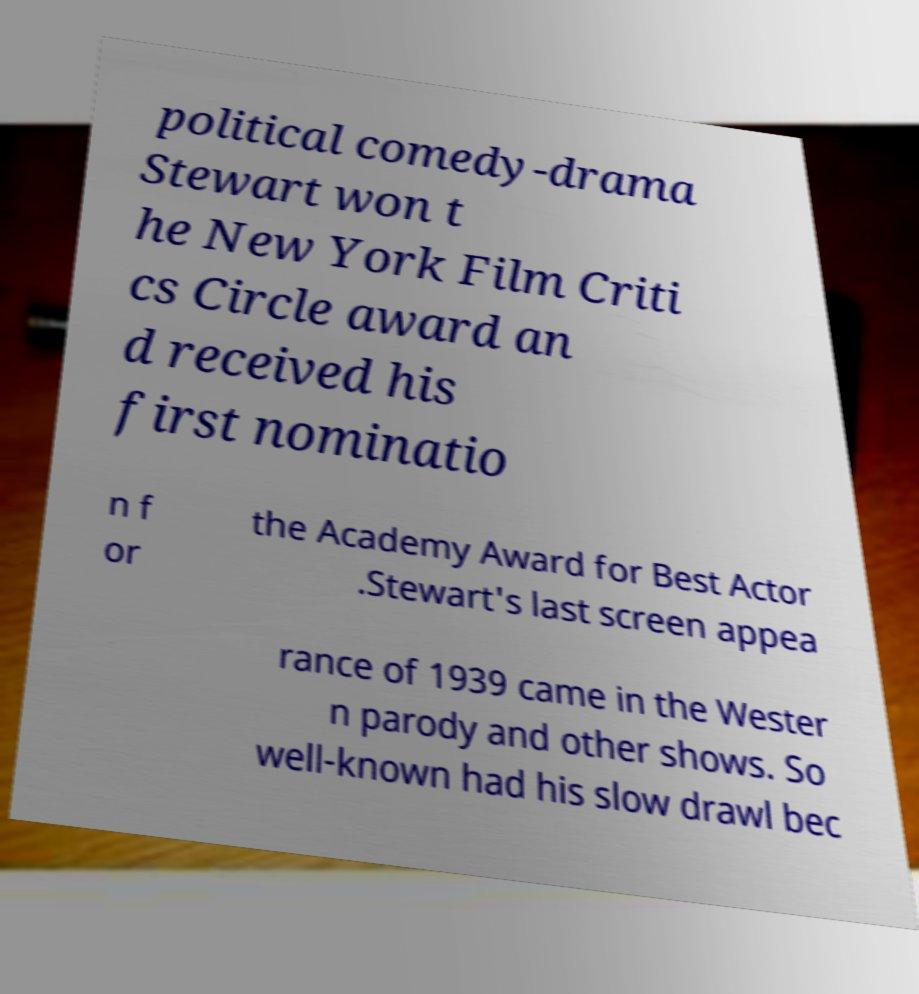For documentation purposes, I need the text within this image transcribed. Could you provide that? political comedy-drama Stewart won t he New York Film Criti cs Circle award an d received his first nominatio n f or the Academy Award for Best Actor .Stewart's last screen appea rance of 1939 came in the Wester n parody and other shows. So well-known had his slow drawl bec 